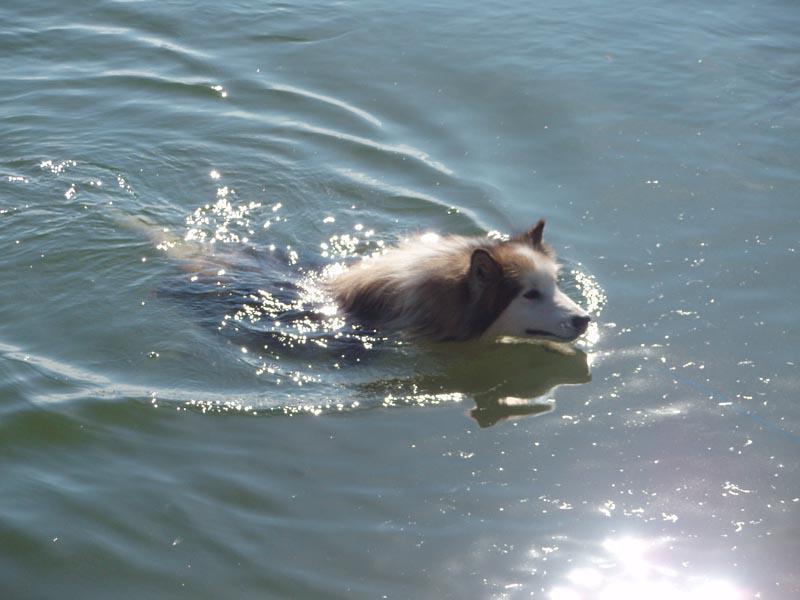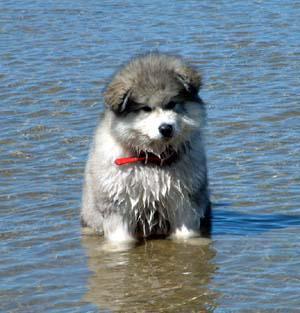The first image is the image on the left, the second image is the image on the right. Examine the images to the left and right. Is the description "All of the dogs are in the water." accurate? Answer yes or no. Yes. The first image is the image on the left, the second image is the image on the right. Examine the images to the left and right. Is the description "Each image shows a dog in the water, with one of the dog's pictured facing directly forward and wearing a red collar." accurate? Answer yes or no. Yes. 